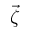<formula> <loc_0><loc_0><loc_500><loc_500>\vec { \zeta }</formula> 